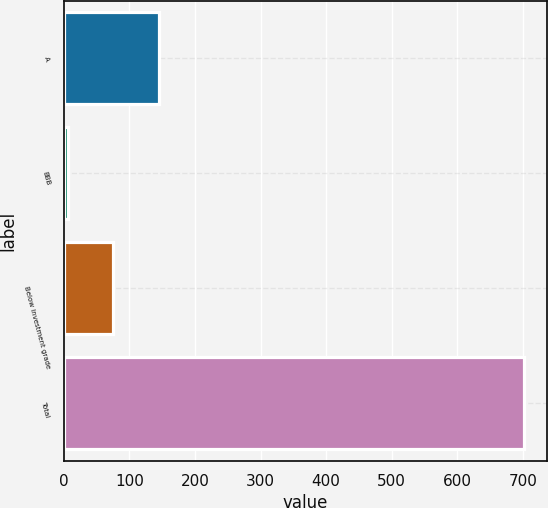Convert chart to OTSL. <chart><loc_0><loc_0><loc_500><loc_500><bar_chart><fcel>A<fcel>BBB<fcel>Below investment grade<fcel>Total<nl><fcel>145.2<fcel>6<fcel>75.6<fcel>702<nl></chart> 